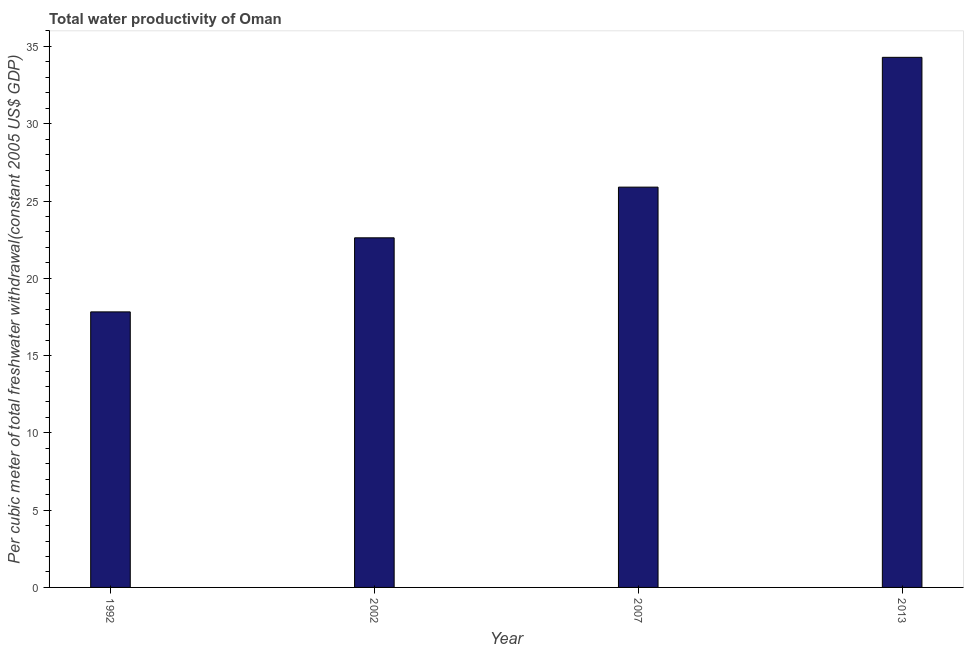Does the graph contain any zero values?
Make the answer very short. No. Does the graph contain grids?
Offer a very short reply. No. What is the title of the graph?
Offer a very short reply. Total water productivity of Oman. What is the label or title of the Y-axis?
Your answer should be very brief. Per cubic meter of total freshwater withdrawal(constant 2005 US$ GDP). What is the total water productivity in 2002?
Your answer should be very brief. 22.62. Across all years, what is the maximum total water productivity?
Make the answer very short. 34.3. Across all years, what is the minimum total water productivity?
Your response must be concise. 17.83. What is the sum of the total water productivity?
Your response must be concise. 100.64. What is the difference between the total water productivity in 2007 and 2013?
Your answer should be compact. -8.4. What is the average total water productivity per year?
Provide a succinct answer. 25.16. What is the median total water productivity?
Make the answer very short. 24.26. In how many years, is the total water productivity greater than 14 US$?
Your response must be concise. 4. What is the ratio of the total water productivity in 2007 to that in 2013?
Keep it short and to the point. 0.76. Is the total water productivity in 1992 less than that in 2002?
Make the answer very short. Yes. What is the difference between the highest and the second highest total water productivity?
Offer a very short reply. 8.4. Is the sum of the total water productivity in 1992 and 2013 greater than the maximum total water productivity across all years?
Offer a very short reply. Yes. What is the difference between the highest and the lowest total water productivity?
Offer a very short reply. 16.47. How many bars are there?
Your answer should be compact. 4. Are all the bars in the graph horizontal?
Ensure brevity in your answer.  No. How many years are there in the graph?
Provide a succinct answer. 4. What is the difference between two consecutive major ticks on the Y-axis?
Offer a very short reply. 5. Are the values on the major ticks of Y-axis written in scientific E-notation?
Your answer should be compact. No. What is the Per cubic meter of total freshwater withdrawal(constant 2005 US$ GDP) in 1992?
Keep it short and to the point. 17.83. What is the Per cubic meter of total freshwater withdrawal(constant 2005 US$ GDP) in 2002?
Keep it short and to the point. 22.62. What is the Per cubic meter of total freshwater withdrawal(constant 2005 US$ GDP) of 2007?
Make the answer very short. 25.9. What is the Per cubic meter of total freshwater withdrawal(constant 2005 US$ GDP) of 2013?
Keep it short and to the point. 34.3. What is the difference between the Per cubic meter of total freshwater withdrawal(constant 2005 US$ GDP) in 1992 and 2002?
Your answer should be compact. -4.79. What is the difference between the Per cubic meter of total freshwater withdrawal(constant 2005 US$ GDP) in 1992 and 2007?
Your answer should be compact. -8.07. What is the difference between the Per cubic meter of total freshwater withdrawal(constant 2005 US$ GDP) in 1992 and 2013?
Offer a terse response. -16.47. What is the difference between the Per cubic meter of total freshwater withdrawal(constant 2005 US$ GDP) in 2002 and 2007?
Give a very brief answer. -3.28. What is the difference between the Per cubic meter of total freshwater withdrawal(constant 2005 US$ GDP) in 2002 and 2013?
Make the answer very short. -11.68. What is the difference between the Per cubic meter of total freshwater withdrawal(constant 2005 US$ GDP) in 2007 and 2013?
Provide a short and direct response. -8.4. What is the ratio of the Per cubic meter of total freshwater withdrawal(constant 2005 US$ GDP) in 1992 to that in 2002?
Your answer should be compact. 0.79. What is the ratio of the Per cubic meter of total freshwater withdrawal(constant 2005 US$ GDP) in 1992 to that in 2007?
Make the answer very short. 0.69. What is the ratio of the Per cubic meter of total freshwater withdrawal(constant 2005 US$ GDP) in 1992 to that in 2013?
Provide a short and direct response. 0.52. What is the ratio of the Per cubic meter of total freshwater withdrawal(constant 2005 US$ GDP) in 2002 to that in 2007?
Offer a terse response. 0.87. What is the ratio of the Per cubic meter of total freshwater withdrawal(constant 2005 US$ GDP) in 2002 to that in 2013?
Give a very brief answer. 0.66. What is the ratio of the Per cubic meter of total freshwater withdrawal(constant 2005 US$ GDP) in 2007 to that in 2013?
Provide a short and direct response. 0.76. 